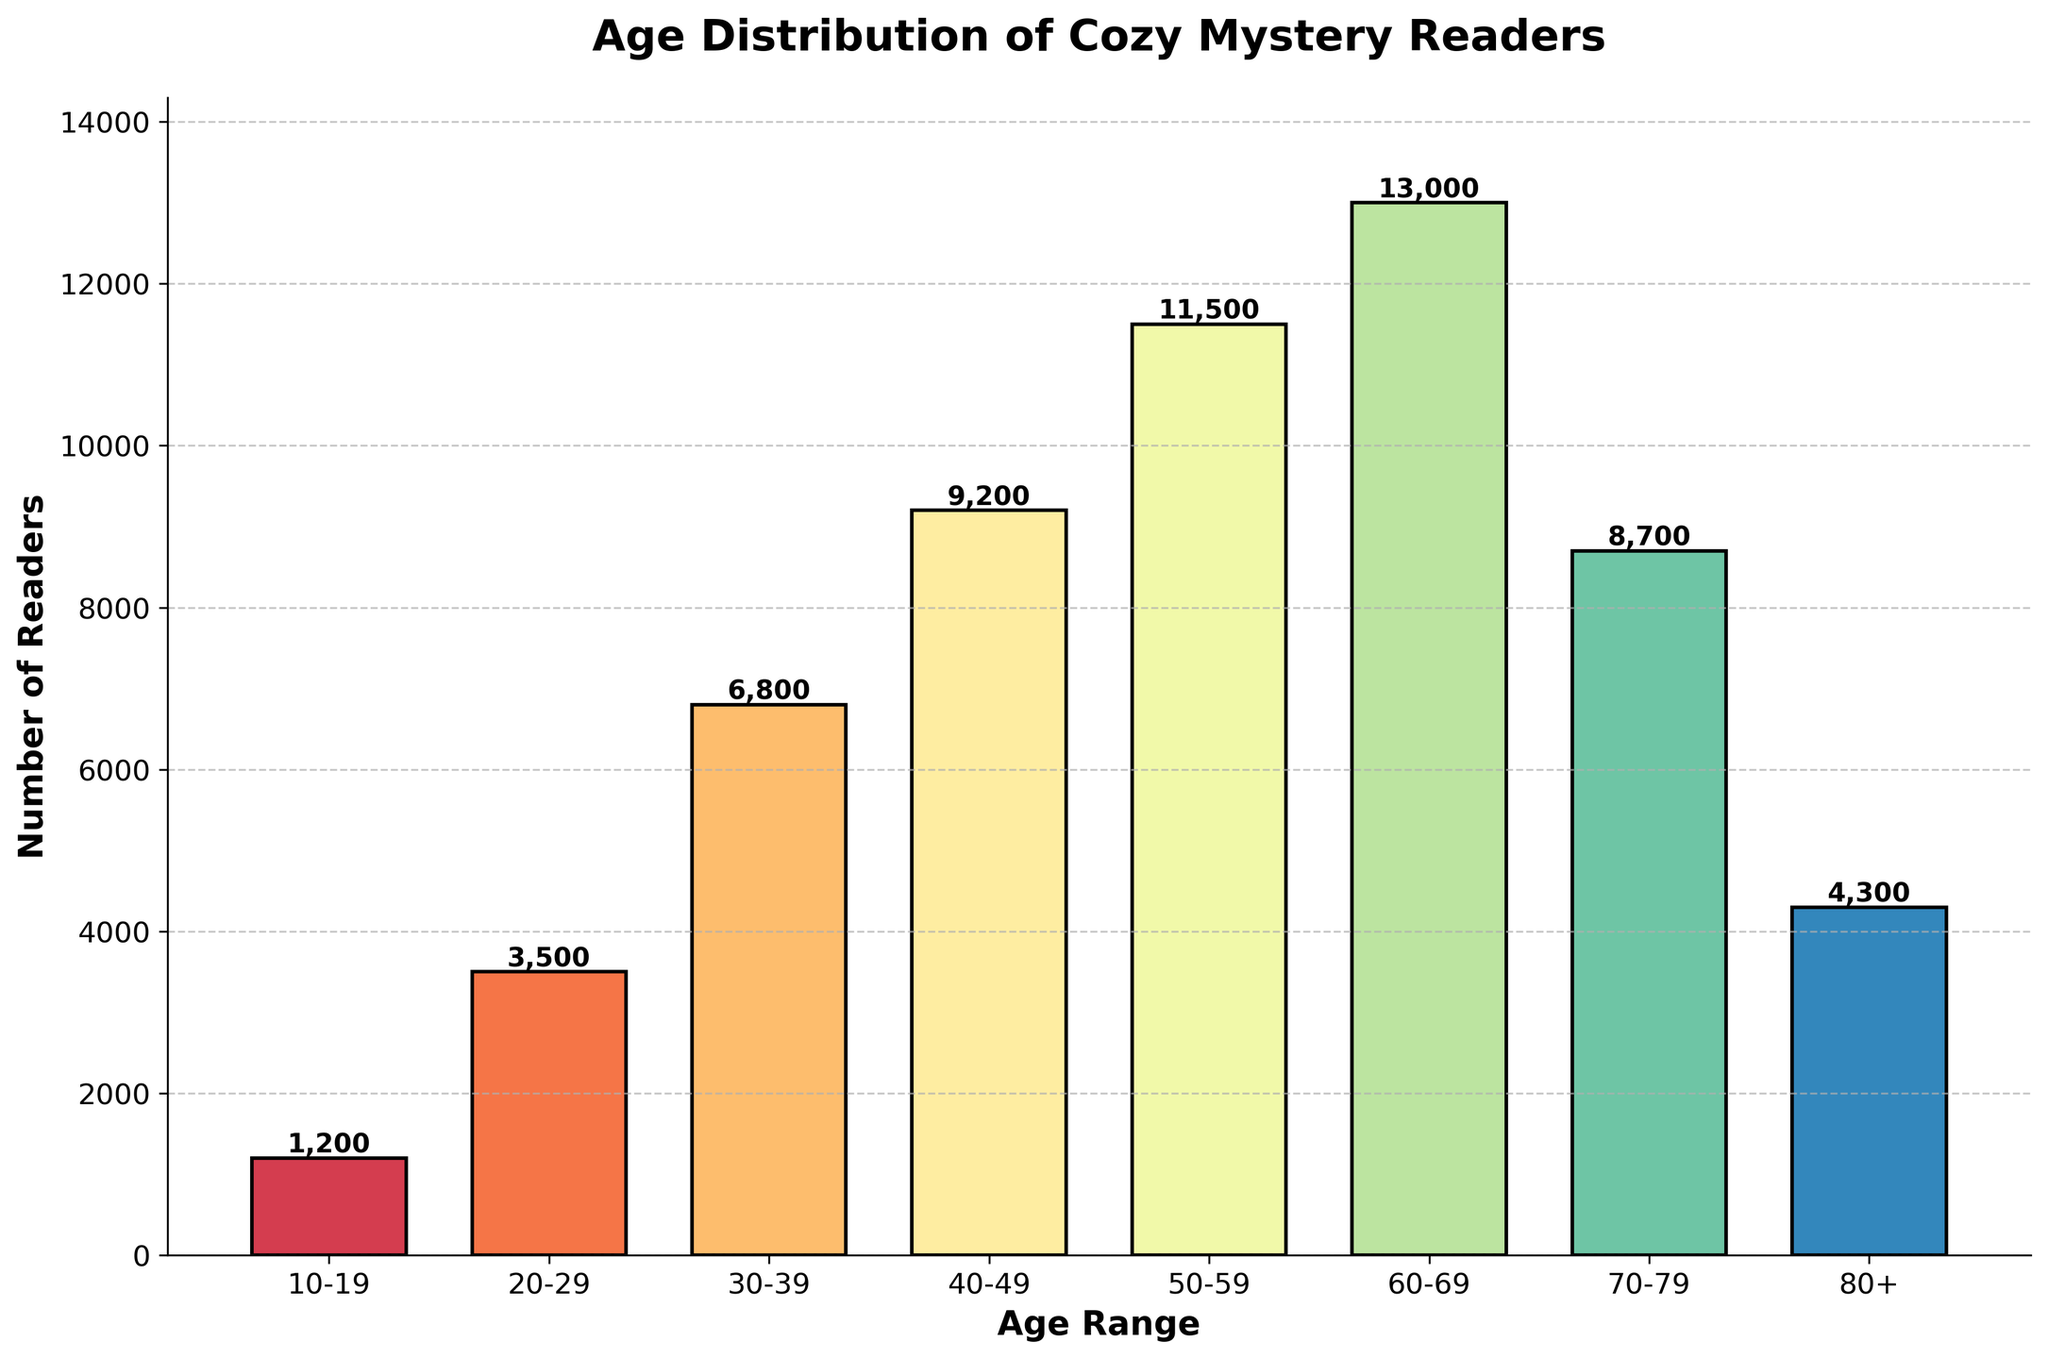What's the age distribution in this histogram title? The title of the histogram can usually be found at the top of the chart. The title helps us understand what the graph is about.
Answer: Age Distribution of Cozy Mystery Readers How many age ranges are shown in the histogram? You can determine the number of age ranges by counting the number of bars on the histogram corresponding to different age groups.
Answer: 8 Which age range has the highest number of readers? To find the age range with the highest number of readers, identify the tallest bar in the histogram and note the corresponding age range on the x-axis.
Answer: 60-69 What is the number of readers in the 40-49 age range? Look for the bar that corresponds to the 40-49 age range on the x-axis and find the number indicated above it.
Answer: 9,200 How many total readers are represented in the histogram? Sum the number of readers across all age ranges by adding up the values indicated above each bar.
Answer: 60,200 What is the age range with the lowest number of readers? Look for the shortest bar in the histogram and check the corresponding age range on the x-axis.
Answer: 10-19 Which age group has fewer readers, 20-29 or 70-79? Compare the heights of the bars corresponding to the 20-29 and 70-79 age ranges on the histogram. The shorter bar represents the age group with fewer readers.
Answer: 70-79 By how much does the number of readers in the 50-59 age range exceed those in the 10-19 age range? Subtract the number of readers in the 10-19 age range from the number of readers in the 50-59 age range.
Answer: 10,300 How does the number of readers in the 80+ age range compare to the 30-39 age range? Compare the heights of the bars for the 80+ and 30-39 age ranges, and calculate the difference in their values by subtracting the smaller number from the larger.
Answer: 2,500 fewer readers in 80+ What is the average number of readers across all age ranges? To find the average number of readers, sum the number of readers in all age ranges and then divide by the total number of age ranges.
Answer: 7,525 